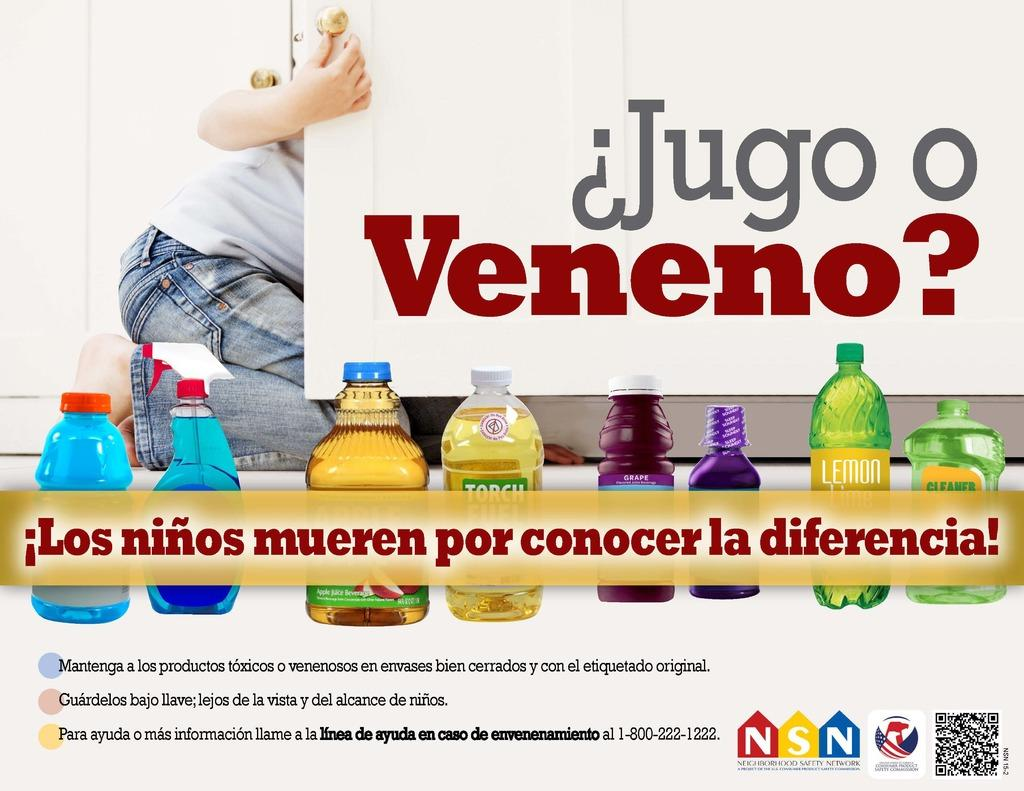<image>
Summarize the visual content of the image. A man in jeans behind a cabinet that says Jugo o Veneno. 